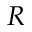<formula> <loc_0><loc_0><loc_500><loc_500>R</formula> 